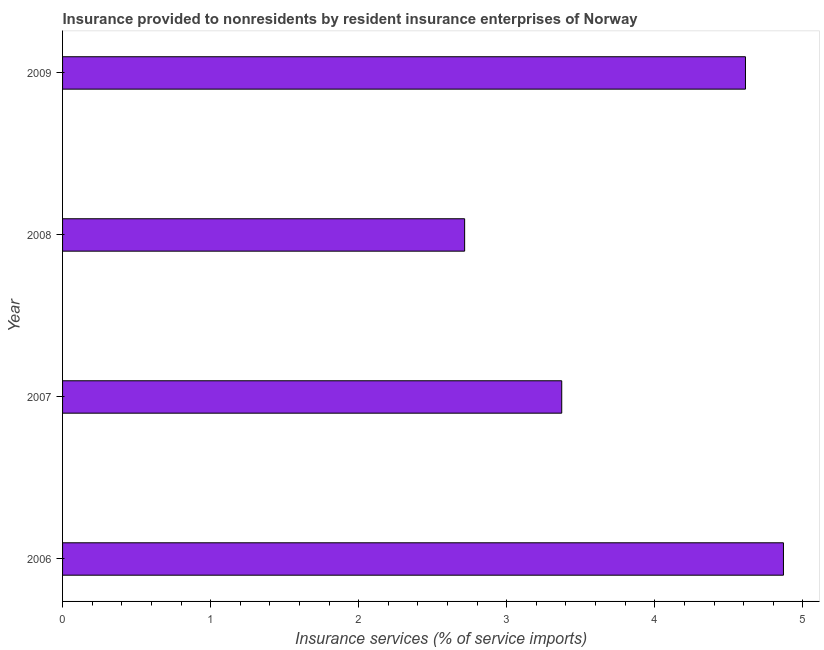Does the graph contain grids?
Make the answer very short. No. What is the title of the graph?
Your answer should be compact. Insurance provided to nonresidents by resident insurance enterprises of Norway. What is the label or title of the X-axis?
Provide a succinct answer. Insurance services (% of service imports). What is the insurance and financial services in 2009?
Ensure brevity in your answer.  4.61. Across all years, what is the maximum insurance and financial services?
Provide a short and direct response. 4.87. Across all years, what is the minimum insurance and financial services?
Provide a succinct answer. 2.72. In which year was the insurance and financial services minimum?
Make the answer very short. 2008. What is the sum of the insurance and financial services?
Your answer should be very brief. 15.57. What is the difference between the insurance and financial services in 2007 and 2008?
Your response must be concise. 0.66. What is the average insurance and financial services per year?
Provide a succinct answer. 3.89. What is the median insurance and financial services?
Your answer should be compact. 3.99. What is the ratio of the insurance and financial services in 2006 to that in 2008?
Provide a short and direct response. 1.79. Is the difference between the insurance and financial services in 2007 and 2008 greater than the difference between any two years?
Your response must be concise. No. What is the difference between the highest and the second highest insurance and financial services?
Offer a very short reply. 0.26. Is the sum of the insurance and financial services in 2007 and 2009 greater than the maximum insurance and financial services across all years?
Offer a terse response. Yes. What is the difference between the highest and the lowest insurance and financial services?
Make the answer very short. 2.15. Are the values on the major ticks of X-axis written in scientific E-notation?
Keep it short and to the point. No. What is the Insurance services (% of service imports) of 2006?
Offer a terse response. 4.87. What is the Insurance services (% of service imports) of 2007?
Make the answer very short. 3.37. What is the Insurance services (% of service imports) in 2008?
Offer a terse response. 2.72. What is the Insurance services (% of service imports) in 2009?
Offer a very short reply. 4.61. What is the difference between the Insurance services (% of service imports) in 2006 and 2007?
Offer a terse response. 1.5. What is the difference between the Insurance services (% of service imports) in 2006 and 2008?
Provide a succinct answer. 2.15. What is the difference between the Insurance services (% of service imports) in 2006 and 2009?
Your response must be concise. 0.26. What is the difference between the Insurance services (% of service imports) in 2007 and 2008?
Make the answer very short. 0.66. What is the difference between the Insurance services (% of service imports) in 2007 and 2009?
Your response must be concise. -1.24. What is the difference between the Insurance services (% of service imports) in 2008 and 2009?
Your answer should be very brief. -1.9. What is the ratio of the Insurance services (% of service imports) in 2006 to that in 2007?
Provide a succinct answer. 1.44. What is the ratio of the Insurance services (% of service imports) in 2006 to that in 2008?
Your response must be concise. 1.79. What is the ratio of the Insurance services (% of service imports) in 2006 to that in 2009?
Keep it short and to the point. 1.06. What is the ratio of the Insurance services (% of service imports) in 2007 to that in 2008?
Provide a short and direct response. 1.24. What is the ratio of the Insurance services (% of service imports) in 2007 to that in 2009?
Your answer should be compact. 0.73. What is the ratio of the Insurance services (% of service imports) in 2008 to that in 2009?
Provide a short and direct response. 0.59. 